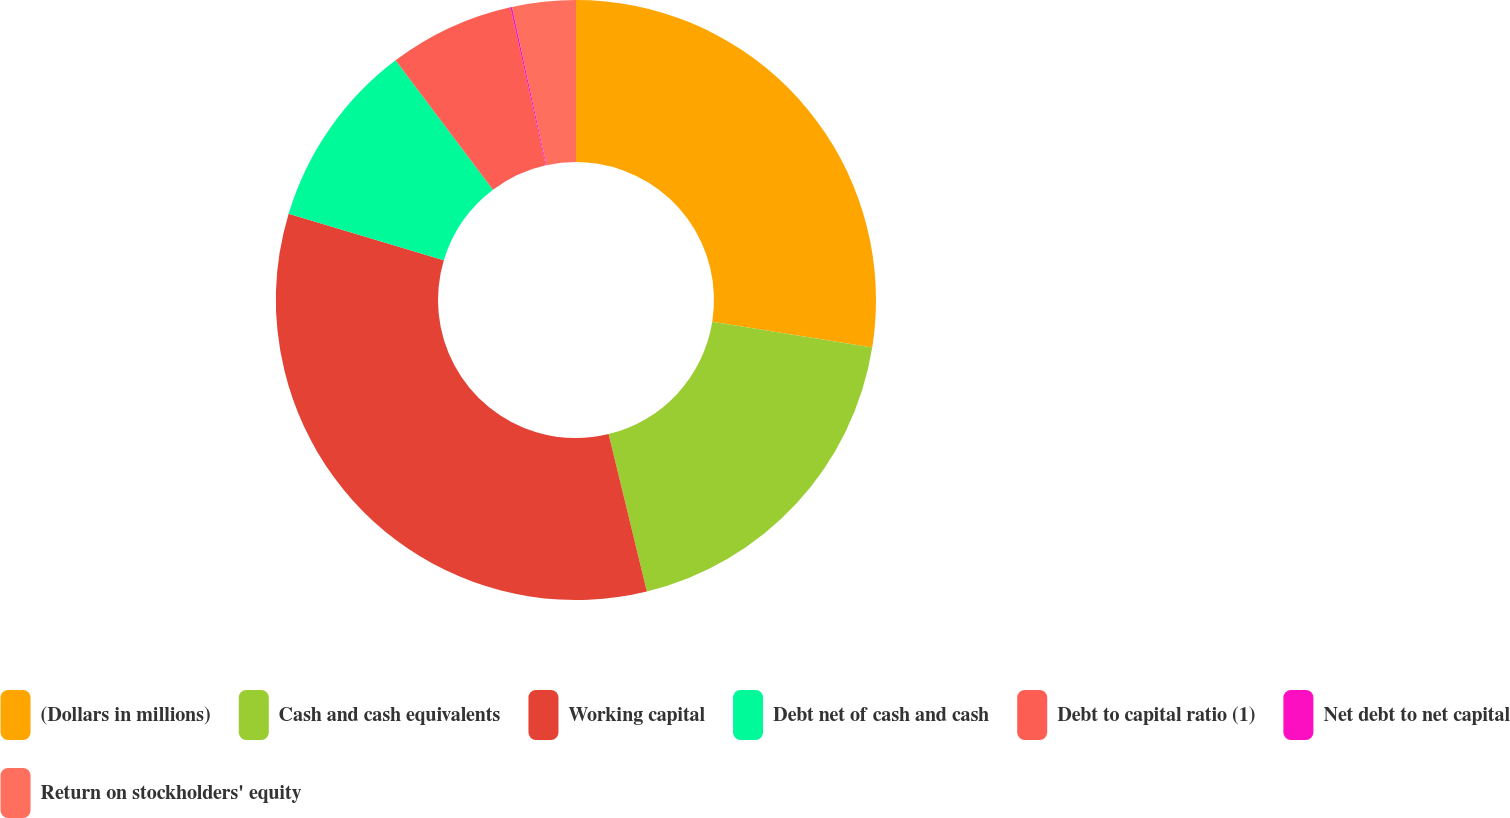<chart> <loc_0><loc_0><loc_500><loc_500><pie_chart><fcel>(Dollars in millions)<fcel>Cash and cash equivalents<fcel>Working capital<fcel>Debt net of cash and cash<fcel>Debt to capital ratio (1)<fcel>Net debt to net capital<fcel>Return on stockholders' equity<nl><fcel>27.53%<fcel>18.67%<fcel>33.43%<fcel>10.09%<fcel>6.76%<fcel>0.09%<fcel>3.42%<nl></chart> 